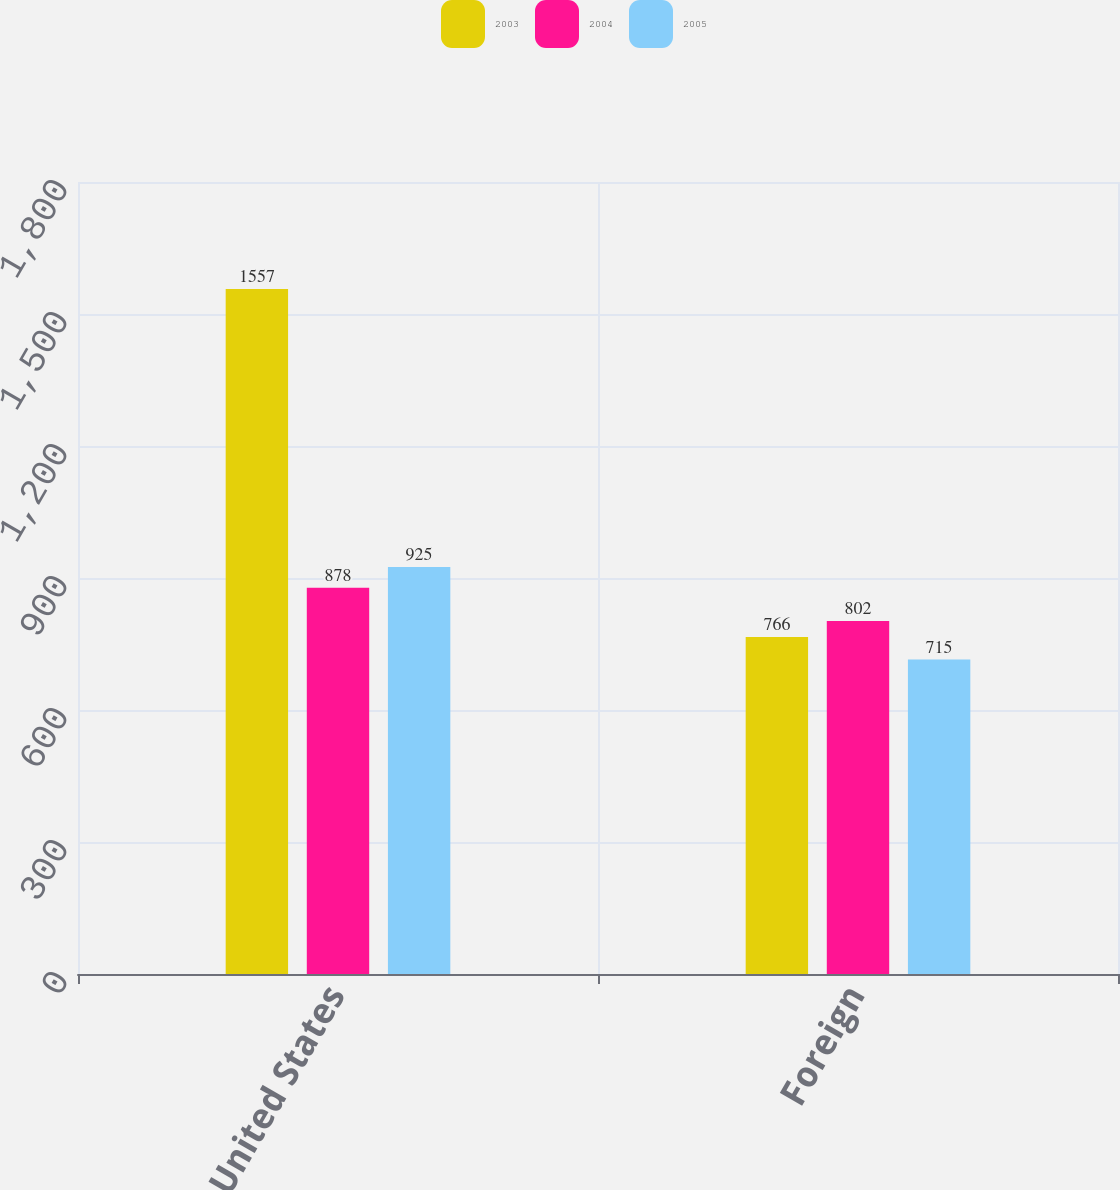Convert chart. <chart><loc_0><loc_0><loc_500><loc_500><stacked_bar_chart><ecel><fcel>United States<fcel>Foreign<nl><fcel>2003<fcel>1557<fcel>766<nl><fcel>2004<fcel>878<fcel>802<nl><fcel>2005<fcel>925<fcel>715<nl></chart> 